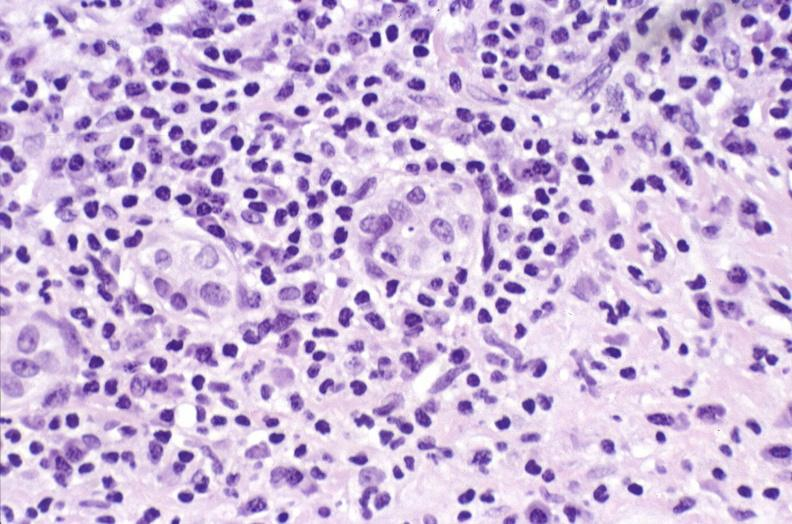s pulmonary osteoarthropathy present?
Answer the question using a single word or phrase. No 